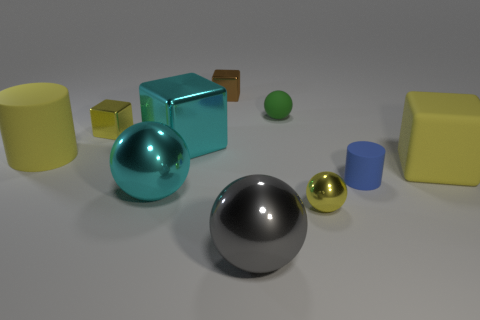What material is the big cube that is on the right side of the small metallic thing that is in front of the cyan sphere?
Offer a very short reply. Rubber. There is a brown object behind the large sphere that is in front of the yellow metallic object that is on the right side of the gray ball; how big is it?
Keep it short and to the point. Small. Do the small brown metal object and the rubber object behind the small yellow metal block have the same shape?
Your response must be concise. No. What is the tiny blue cylinder made of?
Give a very brief answer. Rubber. How many metal objects are gray spheres or brown cubes?
Provide a short and direct response. 2. Is the number of small yellow metallic things in front of the big matte cube less than the number of big yellow rubber cylinders that are right of the big cyan block?
Provide a short and direct response. No. Are there any green spheres that are in front of the cylinder that is behind the big yellow thing that is on the right side of the blue cylinder?
Your answer should be compact. No. What material is the cylinder that is the same color as the tiny metallic sphere?
Provide a succinct answer. Rubber. There is a yellow matte thing that is to the left of the big gray metallic ball; does it have the same shape as the small yellow metallic object in front of the yellow metal cube?
Your response must be concise. No. There is a cylinder that is the same size as the yellow matte cube; what is it made of?
Your answer should be compact. Rubber. 